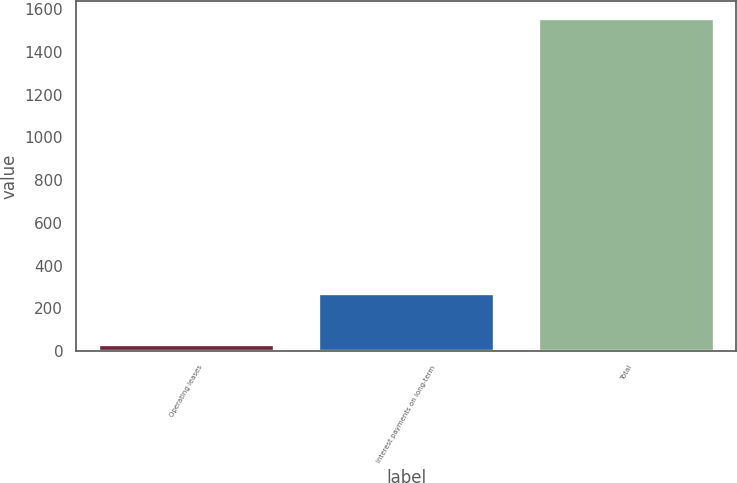Convert chart to OTSL. <chart><loc_0><loc_0><loc_500><loc_500><bar_chart><fcel>Operating leases<fcel>Interest payments on long-term<fcel>Total<nl><fcel>34.5<fcel>274.4<fcel>1559.6<nl></chart> 